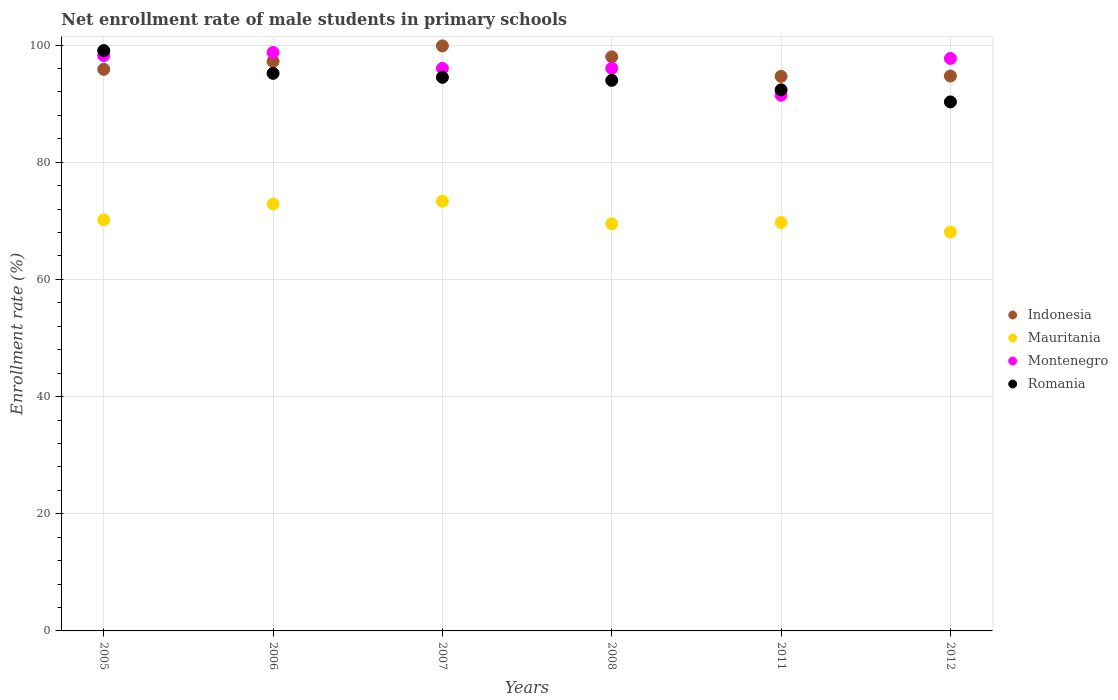Is the number of dotlines equal to the number of legend labels?
Provide a short and direct response. Yes. What is the net enrollment rate of male students in primary schools in Indonesia in 2012?
Make the answer very short. 94.72. Across all years, what is the maximum net enrollment rate of male students in primary schools in Mauritania?
Provide a short and direct response. 73.36. Across all years, what is the minimum net enrollment rate of male students in primary schools in Indonesia?
Your response must be concise. 94.66. What is the total net enrollment rate of male students in primary schools in Indonesia in the graph?
Provide a succinct answer. 580.29. What is the difference between the net enrollment rate of male students in primary schools in Montenegro in 2006 and that in 2007?
Your response must be concise. 2.71. What is the difference between the net enrollment rate of male students in primary schools in Indonesia in 2008 and the net enrollment rate of male students in primary schools in Romania in 2007?
Ensure brevity in your answer.  3.49. What is the average net enrollment rate of male students in primary schools in Montenegro per year?
Offer a very short reply. 96.36. In the year 2008, what is the difference between the net enrollment rate of male students in primary schools in Mauritania and net enrollment rate of male students in primary schools in Romania?
Provide a short and direct response. -24.48. In how many years, is the net enrollment rate of male students in primary schools in Romania greater than 8 %?
Your answer should be very brief. 6. What is the ratio of the net enrollment rate of male students in primary schools in Indonesia in 2011 to that in 2012?
Provide a short and direct response. 1. Is the net enrollment rate of male students in primary schools in Mauritania in 2005 less than that in 2012?
Ensure brevity in your answer.  No. Is the difference between the net enrollment rate of male students in primary schools in Mauritania in 2005 and 2007 greater than the difference between the net enrollment rate of male students in primary schools in Romania in 2005 and 2007?
Ensure brevity in your answer.  No. What is the difference between the highest and the second highest net enrollment rate of male students in primary schools in Indonesia?
Provide a succinct answer. 1.88. What is the difference between the highest and the lowest net enrollment rate of male students in primary schools in Mauritania?
Your response must be concise. 5.27. In how many years, is the net enrollment rate of male students in primary schools in Romania greater than the average net enrollment rate of male students in primary schools in Romania taken over all years?
Give a very brief answer. 3. Is the sum of the net enrollment rate of male students in primary schools in Montenegro in 2006 and 2012 greater than the maximum net enrollment rate of male students in primary schools in Romania across all years?
Your answer should be compact. Yes. Does the net enrollment rate of male students in primary schools in Montenegro monotonically increase over the years?
Make the answer very short. No. Is the net enrollment rate of male students in primary schools in Indonesia strictly greater than the net enrollment rate of male students in primary schools in Mauritania over the years?
Make the answer very short. Yes. How many dotlines are there?
Give a very brief answer. 4. Are the values on the major ticks of Y-axis written in scientific E-notation?
Keep it short and to the point. No. Does the graph contain any zero values?
Make the answer very short. No. Where does the legend appear in the graph?
Provide a short and direct response. Center right. How are the legend labels stacked?
Your response must be concise. Vertical. What is the title of the graph?
Ensure brevity in your answer.  Net enrollment rate of male students in primary schools. What is the label or title of the X-axis?
Your response must be concise. Years. What is the label or title of the Y-axis?
Make the answer very short. Enrollment rate (%). What is the Enrollment rate (%) in Indonesia in 2005?
Give a very brief answer. 95.86. What is the Enrollment rate (%) in Mauritania in 2005?
Your answer should be very brief. 70.17. What is the Enrollment rate (%) of Montenegro in 2005?
Ensure brevity in your answer.  98.2. What is the Enrollment rate (%) of Romania in 2005?
Offer a very short reply. 99.06. What is the Enrollment rate (%) of Indonesia in 2006?
Your response must be concise. 97.21. What is the Enrollment rate (%) in Mauritania in 2006?
Ensure brevity in your answer.  72.87. What is the Enrollment rate (%) in Montenegro in 2006?
Your answer should be very brief. 98.73. What is the Enrollment rate (%) in Romania in 2006?
Give a very brief answer. 95.18. What is the Enrollment rate (%) of Indonesia in 2007?
Provide a succinct answer. 99.86. What is the Enrollment rate (%) in Mauritania in 2007?
Your answer should be compact. 73.36. What is the Enrollment rate (%) of Montenegro in 2007?
Your response must be concise. 96.02. What is the Enrollment rate (%) in Romania in 2007?
Offer a terse response. 94.49. What is the Enrollment rate (%) in Indonesia in 2008?
Ensure brevity in your answer.  97.99. What is the Enrollment rate (%) of Mauritania in 2008?
Offer a very short reply. 69.5. What is the Enrollment rate (%) in Montenegro in 2008?
Keep it short and to the point. 96.04. What is the Enrollment rate (%) in Romania in 2008?
Give a very brief answer. 93.98. What is the Enrollment rate (%) of Indonesia in 2011?
Offer a very short reply. 94.66. What is the Enrollment rate (%) in Mauritania in 2011?
Offer a very short reply. 69.7. What is the Enrollment rate (%) in Montenegro in 2011?
Provide a succinct answer. 91.44. What is the Enrollment rate (%) in Romania in 2011?
Your response must be concise. 92.36. What is the Enrollment rate (%) in Indonesia in 2012?
Offer a terse response. 94.72. What is the Enrollment rate (%) of Mauritania in 2012?
Give a very brief answer. 68.08. What is the Enrollment rate (%) in Montenegro in 2012?
Give a very brief answer. 97.72. What is the Enrollment rate (%) of Romania in 2012?
Your answer should be very brief. 90.3. Across all years, what is the maximum Enrollment rate (%) of Indonesia?
Provide a succinct answer. 99.86. Across all years, what is the maximum Enrollment rate (%) of Mauritania?
Provide a succinct answer. 73.36. Across all years, what is the maximum Enrollment rate (%) of Montenegro?
Make the answer very short. 98.73. Across all years, what is the maximum Enrollment rate (%) of Romania?
Provide a succinct answer. 99.06. Across all years, what is the minimum Enrollment rate (%) in Indonesia?
Provide a short and direct response. 94.66. Across all years, what is the minimum Enrollment rate (%) of Mauritania?
Your answer should be very brief. 68.08. Across all years, what is the minimum Enrollment rate (%) in Montenegro?
Give a very brief answer. 91.44. Across all years, what is the minimum Enrollment rate (%) in Romania?
Offer a terse response. 90.3. What is the total Enrollment rate (%) of Indonesia in the graph?
Provide a succinct answer. 580.29. What is the total Enrollment rate (%) in Mauritania in the graph?
Make the answer very short. 423.67. What is the total Enrollment rate (%) in Montenegro in the graph?
Provide a short and direct response. 578.16. What is the total Enrollment rate (%) of Romania in the graph?
Your response must be concise. 565.36. What is the difference between the Enrollment rate (%) of Indonesia in 2005 and that in 2006?
Provide a succinct answer. -1.35. What is the difference between the Enrollment rate (%) of Mauritania in 2005 and that in 2006?
Give a very brief answer. -2.7. What is the difference between the Enrollment rate (%) of Montenegro in 2005 and that in 2006?
Give a very brief answer. -0.53. What is the difference between the Enrollment rate (%) of Romania in 2005 and that in 2006?
Provide a succinct answer. 3.88. What is the difference between the Enrollment rate (%) in Indonesia in 2005 and that in 2007?
Keep it short and to the point. -4. What is the difference between the Enrollment rate (%) in Mauritania in 2005 and that in 2007?
Provide a short and direct response. -3.19. What is the difference between the Enrollment rate (%) of Montenegro in 2005 and that in 2007?
Offer a very short reply. 2.18. What is the difference between the Enrollment rate (%) of Romania in 2005 and that in 2007?
Your answer should be very brief. 4.57. What is the difference between the Enrollment rate (%) in Indonesia in 2005 and that in 2008?
Keep it short and to the point. -2.13. What is the difference between the Enrollment rate (%) in Mauritania in 2005 and that in 2008?
Keep it short and to the point. 0.67. What is the difference between the Enrollment rate (%) in Montenegro in 2005 and that in 2008?
Make the answer very short. 2.16. What is the difference between the Enrollment rate (%) of Romania in 2005 and that in 2008?
Your answer should be compact. 5.08. What is the difference between the Enrollment rate (%) of Indonesia in 2005 and that in 2011?
Provide a short and direct response. 1.2. What is the difference between the Enrollment rate (%) of Mauritania in 2005 and that in 2011?
Your answer should be compact. 0.46. What is the difference between the Enrollment rate (%) of Montenegro in 2005 and that in 2011?
Offer a terse response. 6.77. What is the difference between the Enrollment rate (%) in Romania in 2005 and that in 2011?
Give a very brief answer. 6.7. What is the difference between the Enrollment rate (%) in Indonesia in 2005 and that in 2012?
Provide a short and direct response. 1.14. What is the difference between the Enrollment rate (%) of Mauritania in 2005 and that in 2012?
Make the answer very short. 2.08. What is the difference between the Enrollment rate (%) of Montenegro in 2005 and that in 2012?
Keep it short and to the point. 0.48. What is the difference between the Enrollment rate (%) in Romania in 2005 and that in 2012?
Keep it short and to the point. 8.76. What is the difference between the Enrollment rate (%) of Indonesia in 2006 and that in 2007?
Your answer should be very brief. -2.65. What is the difference between the Enrollment rate (%) of Mauritania in 2006 and that in 2007?
Offer a terse response. -0.49. What is the difference between the Enrollment rate (%) of Montenegro in 2006 and that in 2007?
Provide a succinct answer. 2.71. What is the difference between the Enrollment rate (%) in Romania in 2006 and that in 2007?
Offer a terse response. 0.69. What is the difference between the Enrollment rate (%) in Indonesia in 2006 and that in 2008?
Your answer should be compact. -0.78. What is the difference between the Enrollment rate (%) of Mauritania in 2006 and that in 2008?
Provide a succinct answer. 3.37. What is the difference between the Enrollment rate (%) of Montenegro in 2006 and that in 2008?
Offer a terse response. 2.7. What is the difference between the Enrollment rate (%) in Romania in 2006 and that in 2008?
Your answer should be compact. 1.2. What is the difference between the Enrollment rate (%) in Indonesia in 2006 and that in 2011?
Make the answer very short. 2.55. What is the difference between the Enrollment rate (%) of Mauritania in 2006 and that in 2011?
Offer a very short reply. 3.16. What is the difference between the Enrollment rate (%) of Montenegro in 2006 and that in 2011?
Provide a short and direct response. 7.3. What is the difference between the Enrollment rate (%) of Romania in 2006 and that in 2011?
Offer a terse response. 2.82. What is the difference between the Enrollment rate (%) in Indonesia in 2006 and that in 2012?
Provide a short and direct response. 2.49. What is the difference between the Enrollment rate (%) in Mauritania in 2006 and that in 2012?
Keep it short and to the point. 4.79. What is the difference between the Enrollment rate (%) in Montenegro in 2006 and that in 2012?
Your answer should be very brief. 1.01. What is the difference between the Enrollment rate (%) of Romania in 2006 and that in 2012?
Provide a short and direct response. 4.88. What is the difference between the Enrollment rate (%) of Indonesia in 2007 and that in 2008?
Ensure brevity in your answer.  1.88. What is the difference between the Enrollment rate (%) in Mauritania in 2007 and that in 2008?
Provide a short and direct response. 3.86. What is the difference between the Enrollment rate (%) in Montenegro in 2007 and that in 2008?
Give a very brief answer. -0.02. What is the difference between the Enrollment rate (%) in Romania in 2007 and that in 2008?
Give a very brief answer. 0.52. What is the difference between the Enrollment rate (%) of Indonesia in 2007 and that in 2011?
Provide a succinct answer. 5.2. What is the difference between the Enrollment rate (%) of Mauritania in 2007 and that in 2011?
Give a very brief answer. 3.65. What is the difference between the Enrollment rate (%) in Montenegro in 2007 and that in 2011?
Your answer should be very brief. 4.59. What is the difference between the Enrollment rate (%) in Romania in 2007 and that in 2011?
Keep it short and to the point. 2.13. What is the difference between the Enrollment rate (%) in Indonesia in 2007 and that in 2012?
Your answer should be very brief. 5.14. What is the difference between the Enrollment rate (%) in Mauritania in 2007 and that in 2012?
Your response must be concise. 5.27. What is the difference between the Enrollment rate (%) of Montenegro in 2007 and that in 2012?
Your response must be concise. -1.7. What is the difference between the Enrollment rate (%) of Romania in 2007 and that in 2012?
Your answer should be very brief. 4.19. What is the difference between the Enrollment rate (%) of Indonesia in 2008 and that in 2011?
Keep it short and to the point. 3.33. What is the difference between the Enrollment rate (%) in Mauritania in 2008 and that in 2011?
Keep it short and to the point. -0.2. What is the difference between the Enrollment rate (%) in Montenegro in 2008 and that in 2011?
Your answer should be very brief. 4.6. What is the difference between the Enrollment rate (%) in Romania in 2008 and that in 2011?
Provide a short and direct response. 1.61. What is the difference between the Enrollment rate (%) in Indonesia in 2008 and that in 2012?
Your answer should be very brief. 3.27. What is the difference between the Enrollment rate (%) in Mauritania in 2008 and that in 2012?
Your response must be concise. 1.42. What is the difference between the Enrollment rate (%) of Montenegro in 2008 and that in 2012?
Keep it short and to the point. -1.68. What is the difference between the Enrollment rate (%) in Romania in 2008 and that in 2012?
Your answer should be compact. 3.68. What is the difference between the Enrollment rate (%) of Indonesia in 2011 and that in 2012?
Your response must be concise. -0.06. What is the difference between the Enrollment rate (%) of Mauritania in 2011 and that in 2012?
Ensure brevity in your answer.  1.62. What is the difference between the Enrollment rate (%) in Montenegro in 2011 and that in 2012?
Your answer should be very brief. -6.29. What is the difference between the Enrollment rate (%) in Romania in 2011 and that in 2012?
Make the answer very short. 2.06. What is the difference between the Enrollment rate (%) of Indonesia in 2005 and the Enrollment rate (%) of Mauritania in 2006?
Your answer should be compact. 22.99. What is the difference between the Enrollment rate (%) of Indonesia in 2005 and the Enrollment rate (%) of Montenegro in 2006?
Your answer should be very brief. -2.88. What is the difference between the Enrollment rate (%) of Indonesia in 2005 and the Enrollment rate (%) of Romania in 2006?
Keep it short and to the point. 0.68. What is the difference between the Enrollment rate (%) of Mauritania in 2005 and the Enrollment rate (%) of Montenegro in 2006?
Offer a very short reply. -28.57. What is the difference between the Enrollment rate (%) in Mauritania in 2005 and the Enrollment rate (%) in Romania in 2006?
Provide a short and direct response. -25.01. What is the difference between the Enrollment rate (%) of Montenegro in 2005 and the Enrollment rate (%) of Romania in 2006?
Make the answer very short. 3.03. What is the difference between the Enrollment rate (%) in Indonesia in 2005 and the Enrollment rate (%) in Mauritania in 2007?
Make the answer very short. 22.5. What is the difference between the Enrollment rate (%) of Indonesia in 2005 and the Enrollment rate (%) of Montenegro in 2007?
Give a very brief answer. -0.17. What is the difference between the Enrollment rate (%) of Indonesia in 2005 and the Enrollment rate (%) of Romania in 2007?
Your response must be concise. 1.37. What is the difference between the Enrollment rate (%) in Mauritania in 2005 and the Enrollment rate (%) in Montenegro in 2007?
Keep it short and to the point. -25.86. What is the difference between the Enrollment rate (%) of Mauritania in 2005 and the Enrollment rate (%) of Romania in 2007?
Offer a very short reply. -24.33. What is the difference between the Enrollment rate (%) of Montenegro in 2005 and the Enrollment rate (%) of Romania in 2007?
Offer a very short reply. 3.71. What is the difference between the Enrollment rate (%) in Indonesia in 2005 and the Enrollment rate (%) in Mauritania in 2008?
Make the answer very short. 26.36. What is the difference between the Enrollment rate (%) in Indonesia in 2005 and the Enrollment rate (%) in Montenegro in 2008?
Your answer should be compact. -0.18. What is the difference between the Enrollment rate (%) in Indonesia in 2005 and the Enrollment rate (%) in Romania in 2008?
Your answer should be very brief. 1.88. What is the difference between the Enrollment rate (%) in Mauritania in 2005 and the Enrollment rate (%) in Montenegro in 2008?
Provide a succinct answer. -25.87. What is the difference between the Enrollment rate (%) in Mauritania in 2005 and the Enrollment rate (%) in Romania in 2008?
Offer a terse response. -23.81. What is the difference between the Enrollment rate (%) in Montenegro in 2005 and the Enrollment rate (%) in Romania in 2008?
Give a very brief answer. 4.23. What is the difference between the Enrollment rate (%) of Indonesia in 2005 and the Enrollment rate (%) of Mauritania in 2011?
Your answer should be very brief. 26.15. What is the difference between the Enrollment rate (%) of Indonesia in 2005 and the Enrollment rate (%) of Montenegro in 2011?
Ensure brevity in your answer.  4.42. What is the difference between the Enrollment rate (%) of Indonesia in 2005 and the Enrollment rate (%) of Romania in 2011?
Offer a terse response. 3.5. What is the difference between the Enrollment rate (%) in Mauritania in 2005 and the Enrollment rate (%) in Montenegro in 2011?
Your answer should be very brief. -21.27. What is the difference between the Enrollment rate (%) in Mauritania in 2005 and the Enrollment rate (%) in Romania in 2011?
Ensure brevity in your answer.  -22.2. What is the difference between the Enrollment rate (%) in Montenegro in 2005 and the Enrollment rate (%) in Romania in 2011?
Your response must be concise. 5.84. What is the difference between the Enrollment rate (%) in Indonesia in 2005 and the Enrollment rate (%) in Mauritania in 2012?
Your answer should be compact. 27.78. What is the difference between the Enrollment rate (%) of Indonesia in 2005 and the Enrollment rate (%) of Montenegro in 2012?
Offer a very short reply. -1.86. What is the difference between the Enrollment rate (%) in Indonesia in 2005 and the Enrollment rate (%) in Romania in 2012?
Give a very brief answer. 5.56. What is the difference between the Enrollment rate (%) in Mauritania in 2005 and the Enrollment rate (%) in Montenegro in 2012?
Offer a terse response. -27.56. What is the difference between the Enrollment rate (%) in Mauritania in 2005 and the Enrollment rate (%) in Romania in 2012?
Your answer should be very brief. -20.13. What is the difference between the Enrollment rate (%) of Montenegro in 2005 and the Enrollment rate (%) of Romania in 2012?
Give a very brief answer. 7.9. What is the difference between the Enrollment rate (%) of Indonesia in 2006 and the Enrollment rate (%) of Mauritania in 2007?
Give a very brief answer. 23.85. What is the difference between the Enrollment rate (%) in Indonesia in 2006 and the Enrollment rate (%) in Montenegro in 2007?
Your answer should be very brief. 1.18. What is the difference between the Enrollment rate (%) of Indonesia in 2006 and the Enrollment rate (%) of Romania in 2007?
Keep it short and to the point. 2.72. What is the difference between the Enrollment rate (%) of Mauritania in 2006 and the Enrollment rate (%) of Montenegro in 2007?
Provide a short and direct response. -23.16. What is the difference between the Enrollment rate (%) of Mauritania in 2006 and the Enrollment rate (%) of Romania in 2007?
Give a very brief answer. -21.63. What is the difference between the Enrollment rate (%) of Montenegro in 2006 and the Enrollment rate (%) of Romania in 2007?
Your answer should be very brief. 4.24. What is the difference between the Enrollment rate (%) in Indonesia in 2006 and the Enrollment rate (%) in Mauritania in 2008?
Offer a terse response. 27.71. What is the difference between the Enrollment rate (%) of Indonesia in 2006 and the Enrollment rate (%) of Montenegro in 2008?
Provide a short and direct response. 1.17. What is the difference between the Enrollment rate (%) of Indonesia in 2006 and the Enrollment rate (%) of Romania in 2008?
Ensure brevity in your answer.  3.23. What is the difference between the Enrollment rate (%) in Mauritania in 2006 and the Enrollment rate (%) in Montenegro in 2008?
Provide a succinct answer. -23.17. What is the difference between the Enrollment rate (%) of Mauritania in 2006 and the Enrollment rate (%) of Romania in 2008?
Provide a succinct answer. -21.11. What is the difference between the Enrollment rate (%) of Montenegro in 2006 and the Enrollment rate (%) of Romania in 2008?
Keep it short and to the point. 4.76. What is the difference between the Enrollment rate (%) of Indonesia in 2006 and the Enrollment rate (%) of Mauritania in 2011?
Offer a very short reply. 27.5. What is the difference between the Enrollment rate (%) in Indonesia in 2006 and the Enrollment rate (%) in Montenegro in 2011?
Your response must be concise. 5.77. What is the difference between the Enrollment rate (%) of Indonesia in 2006 and the Enrollment rate (%) of Romania in 2011?
Your answer should be compact. 4.85. What is the difference between the Enrollment rate (%) of Mauritania in 2006 and the Enrollment rate (%) of Montenegro in 2011?
Your answer should be compact. -18.57. What is the difference between the Enrollment rate (%) in Mauritania in 2006 and the Enrollment rate (%) in Romania in 2011?
Your answer should be compact. -19.49. What is the difference between the Enrollment rate (%) in Montenegro in 2006 and the Enrollment rate (%) in Romania in 2011?
Give a very brief answer. 6.37. What is the difference between the Enrollment rate (%) in Indonesia in 2006 and the Enrollment rate (%) in Mauritania in 2012?
Provide a succinct answer. 29.13. What is the difference between the Enrollment rate (%) of Indonesia in 2006 and the Enrollment rate (%) of Montenegro in 2012?
Offer a very short reply. -0.51. What is the difference between the Enrollment rate (%) in Indonesia in 2006 and the Enrollment rate (%) in Romania in 2012?
Give a very brief answer. 6.91. What is the difference between the Enrollment rate (%) in Mauritania in 2006 and the Enrollment rate (%) in Montenegro in 2012?
Provide a succinct answer. -24.86. What is the difference between the Enrollment rate (%) of Mauritania in 2006 and the Enrollment rate (%) of Romania in 2012?
Keep it short and to the point. -17.43. What is the difference between the Enrollment rate (%) of Montenegro in 2006 and the Enrollment rate (%) of Romania in 2012?
Provide a short and direct response. 8.44. What is the difference between the Enrollment rate (%) in Indonesia in 2007 and the Enrollment rate (%) in Mauritania in 2008?
Provide a short and direct response. 30.36. What is the difference between the Enrollment rate (%) of Indonesia in 2007 and the Enrollment rate (%) of Montenegro in 2008?
Ensure brevity in your answer.  3.82. What is the difference between the Enrollment rate (%) of Indonesia in 2007 and the Enrollment rate (%) of Romania in 2008?
Offer a terse response. 5.89. What is the difference between the Enrollment rate (%) of Mauritania in 2007 and the Enrollment rate (%) of Montenegro in 2008?
Your answer should be compact. -22.68. What is the difference between the Enrollment rate (%) in Mauritania in 2007 and the Enrollment rate (%) in Romania in 2008?
Provide a short and direct response. -20.62. What is the difference between the Enrollment rate (%) of Montenegro in 2007 and the Enrollment rate (%) of Romania in 2008?
Your answer should be compact. 2.05. What is the difference between the Enrollment rate (%) in Indonesia in 2007 and the Enrollment rate (%) in Mauritania in 2011?
Ensure brevity in your answer.  30.16. What is the difference between the Enrollment rate (%) in Indonesia in 2007 and the Enrollment rate (%) in Montenegro in 2011?
Make the answer very short. 8.43. What is the difference between the Enrollment rate (%) of Indonesia in 2007 and the Enrollment rate (%) of Romania in 2011?
Make the answer very short. 7.5. What is the difference between the Enrollment rate (%) in Mauritania in 2007 and the Enrollment rate (%) in Montenegro in 2011?
Make the answer very short. -18.08. What is the difference between the Enrollment rate (%) of Mauritania in 2007 and the Enrollment rate (%) of Romania in 2011?
Make the answer very short. -19. What is the difference between the Enrollment rate (%) of Montenegro in 2007 and the Enrollment rate (%) of Romania in 2011?
Keep it short and to the point. 3.66. What is the difference between the Enrollment rate (%) of Indonesia in 2007 and the Enrollment rate (%) of Mauritania in 2012?
Keep it short and to the point. 31.78. What is the difference between the Enrollment rate (%) of Indonesia in 2007 and the Enrollment rate (%) of Montenegro in 2012?
Make the answer very short. 2.14. What is the difference between the Enrollment rate (%) of Indonesia in 2007 and the Enrollment rate (%) of Romania in 2012?
Your answer should be very brief. 9.56. What is the difference between the Enrollment rate (%) of Mauritania in 2007 and the Enrollment rate (%) of Montenegro in 2012?
Ensure brevity in your answer.  -24.37. What is the difference between the Enrollment rate (%) in Mauritania in 2007 and the Enrollment rate (%) in Romania in 2012?
Ensure brevity in your answer.  -16.94. What is the difference between the Enrollment rate (%) in Montenegro in 2007 and the Enrollment rate (%) in Romania in 2012?
Offer a terse response. 5.73. What is the difference between the Enrollment rate (%) in Indonesia in 2008 and the Enrollment rate (%) in Mauritania in 2011?
Offer a very short reply. 28.28. What is the difference between the Enrollment rate (%) of Indonesia in 2008 and the Enrollment rate (%) of Montenegro in 2011?
Provide a short and direct response. 6.55. What is the difference between the Enrollment rate (%) of Indonesia in 2008 and the Enrollment rate (%) of Romania in 2011?
Keep it short and to the point. 5.63. What is the difference between the Enrollment rate (%) in Mauritania in 2008 and the Enrollment rate (%) in Montenegro in 2011?
Your response must be concise. -21.94. What is the difference between the Enrollment rate (%) of Mauritania in 2008 and the Enrollment rate (%) of Romania in 2011?
Keep it short and to the point. -22.86. What is the difference between the Enrollment rate (%) of Montenegro in 2008 and the Enrollment rate (%) of Romania in 2011?
Offer a very short reply. 3.68. What is the difference between the Enrollment rate (%) of Indonesia in 2008 and the Enrollment rate (%) of Mauritania in 2012?
Your response must be concise. 29.91. What is the difference between the Enrollment rate (%) in Indonesia in 2008 and the Enrollment rate (%) in Montenegro in 2012?
Your answer should be compact. 0.26. What is the difference between the Enrollment rate (%) in Indonesia in 2008 and the Enrollment rate (%) in Romania in 2012?
Make the answer very short. 7.69. What is the difference between the Enrollment rate (%) of Mauritania in 2008 and the Enrollment rate (%) of Montenegro in 2012?
Provide a succinct answer. -28.22. What is the difference between the Enrollment rate (%) of Mauritania in 2008 and the Enrollment rate (%) of Romania in 2012?
Provide a short and direct response. -20.8. What is the difference between the Enrollment rate (%) in Montenegro in 2008 and the Enrollment rate (%) in Romania in 2012?
Your answer should be compact. 5.74. What is the difference between the Enrollment rate (%) of Indonesia in 2011 and the Enrollment rate (%) of Mauritania in 2012?
Keep it short and to the point. 26.58. What is the difference between the Enrollment rate (%) in Indonesia in 2011 and the Enrollment rate (%) in Montenegro in 2012?
Your answer should be compact. -3.06. What is the difference between the Enrollment rate (%) in Indonesia in 2011 and the Enrollment rate (%) in Romania in 2012?
Ensure brevity in your answer.  4.36. What is the difference between the Enrollment rate (%) of Mauritania in 2011 and the Enrollment rate (%) of Montenegro in 2012?
Give a very brief answer. -28.02. What is the difference between the Enrollment rate (%) in Mauritania in 2011 and the Enrollment rate (%) in Romania in 2012?
Your response must be concise. -20.59. What is the difference between the Enrollment rate (%) of Montenegro in 2011 and the Enrollment rate (%) of Romania in 2012?
Your response must be concise. 1.14. What is the average Enrollment rate (%) of Indonesia per year?
Provide a short and direct response. 96.72. What is the average Enrollment rate (%) in Mauritania per year?
Ensure brevity in your answer.  70.61. What is the average Enrollment rate (%) of Montenegro per year?
Your answer should be very brief. 96.36. What is the average Enrollment rate (%) in Romania per year?
Your answer should be very brief. 94.23. In the year 2005, what is the difference between the Enrollment rate (%) in Indonesia and Enrollment rate (%) in Mauritania?
Offer a very short reply. 25.69. In the year 2005, what is the difference between the Enrollment rate (%) in Indonesia and Enrollment rate (%) in Montenegro?
Ensure brevity in your answer.  -2.35. In the year 2005, what is the difference between the Enrollment rate (%) of Indonesia and Enrollment rate (%) of Romania?
Your response must be concise. -3.2. In the year 2005, what is the difference between the Enrollment rate (%) in Mauritania and Enrollment rate (%) in Montenegro?
Provide a succinct answer. -28.04. In the year 2005, what is the difference between the Enrollment rate (%) in Mauritania and Enrollment rate (%) in Romania?
Provide a succinct answer. -28.89. In the year 2005, what is the difference between the Enrollment rate (%) of Montenegro and Enrollment rate (%) of Romania?
Make the answer very short. -0.86. In the year 2006, what is the difference between the Enrollment rate (%) in Indonesia and Enrollment rate (%) in Mauritania?
Ensure brevity in your answer.  24.34. In the year 2006, what is the difference between the Enrollment rate (%) in Indonesia and Enrollment rate (%) in Montenegro?
Your response must be concise. -1.53. In the year 2006, what is the difference between the Enrollment rate (%) of Indonesia and Enrollment rate (%) of Romania?
Ensure brevity in your answer.  2.03. In the year 2006, what is the difference between the Enrollment rate (%) in Mauritania and Enrollment rate (%) in Montenegro?
Offer a terse response. -25.87. In the year 2006, what is the difference between the Enrollment rate (%) of Mauritania and Enrollment rate (%) of Romania?
Provide a succinct answer. -22.31. In the year 2006, what is the difference between the Enrollment rate (%) of Montenegro and Enrollment rate (%) of Romania?
Ensure brevity in your answer.  3.56. In the year 2007, what is the difference between the Enrollment rate (%) of Indonesia and Enrollment rate (%) of Mauritania?
Make the answer very short. 26.51. In the year 2007, what is the difference between the Enrollment rate (%) of Indonesia and Enrollment rate (%) of Montenegro?
Provide a short and direct response. 3.84. In the year 2007, what is the difference between the Enrollment rate (%) in Indonesia and Enrollment rate (%) in Romania?
Provide a succinct answer. 5.37. In the year 2007, what is the difference between the Enrollment rate (%) of Mauritania and Enrollment rate (%) of Montenegro?
Make the answer very short. -22.67. In the year 2007, what is the difference between the Enrollment rate (%) in Mauritania and Enrollment rate (%) in Romania?
Provide a short and direct response. -21.14. In the year 2007, what is the difference between the Enrollment rate (%) in Montenegro and Enrollment rate (%) in Romania?
Your answer should be very brief. 1.53. In the year 2008, what is the difference between the Enrollment rate (%) in Indonesia and Enrollment rate (%) in Mauritania?
Provide a succinct answer. 28.49. In the year 2008, what is the difference between the Enrollment rate (%) in Indonesia and Enrollment rate (%) in Montenegro?
Your answer should be very brief. 1.95. In the year 2008, what is the difference between the Enrollment rate (%) in Indonesia and Enrollment rate (%) in Romania?
Your answer should be very brief. 4.01. In the year 2008, what is the difference between the Enrollment rate (%) of Mauritania and Enrollment rate (%) of Montenegro?
Offer a terse response. -26.54. In the year 2008, what is the difference between the Enrollment rate (%) of Mauritania and Enrollment rate (%) of Romania?
Offer a terse response. -24.48. In the year 2008, what is the difference between the Enrollment rate (%) in Montenegro and Enrollment rate (%) in Romania?
Your answer should be compact. 2.06. In the year 2011, what is the difference between the Enrollment rate (%) in Indonesia and Enrollment rate (%) in Mauritania?
Your response must be concise. 24.96. In the year 2011, what is the difference between the Enrollment rate (%) in Indonesia and Enrollment rate (%) in Montenegro?
Your answer should be compact. 3.22. In the year 2011, what is the difference between the Enrollment rate (%) of Indonesia and Enrollment rate (%) of Romania?
Ensure brevity in your answer.  2.3. In the year 2011, what is the difference between the Enrollment rate (%) of Mauritania and Enrollment rate (%) of Montenegro?
Give a very brief answer. -21.73. In the year 2011, what is the difference between the Enrollment rate (%) in Mauritania and Enrollment rate (%) in Romania?
Your answer should be very brief. -22.66. In the year 2011, what is the difference between the Enrollment rate (%) of Montenegro and Enrollment rate (%) of Romania?
Your answer should be compact. -0.93. In the year 2012, what is the difference between the Enrollment rate (%) of Indonesia and Enrollment rate (%) of Mauritania?
Keep it short and to the point. 26.64. In the year 2012, what is the difference between the Enrollment rate (%) in Indonesia and Enrollment rate (%) in Montenegro?
Provide a succinct answer. -3. In the year 2012, what is the difference between the Enrollment rate (%) of Indonesia and Enrollment rate (%) of Romania?
Give a very brief answer. 4.42. In the year 2012, what is the difference between the Enrollment rate (%) of Mauritania and Enrollment rate (%) of Montenegro?
Give a very brief answer. -29.64. In the year 2012, what is the difference between the Enrollment rate (%) in Mauritania and Enrollment rate (%) in Romania?
Keep it short and to the point. -22.22. In the year 2012, what is the difference between the Enrollment rate (%) of Montenegro and Enrollment rate (%) of Romania?
Your answer should be very brief. 7.42. What is the ratio of the Enrollment rate (%) of Indonesia in 2005 to that in 2006?
Make the answer very short. 0.99. What is the ratio of the Enrollment rate (%) in Mauritania in 2005 to that in 2006?
Provide a succinct answer. 0.96. What is the ratio of the Enrollment rate (%) in Montenegro in 2005 to that in 2006?
Offer a terse response. 0.99. What is the ratio of the Enrollment rate (%) of Romania in 2005 to that in 2006?
Keep it short and to the point. 1.04. What is the ratio of the Enrollment rate (%) in Indonesia in 2005 to that in 2007?
Ensure brevity in your answer.  0.96. What is the ratio of the Enrollment rate (%) in Mauritania in 2005 to that in 2007?
Provide a short and direct response. 0.96. What is the ratio of the Enrollment rate (%) in Montenegro in 2005 to that in 2007?
Make the answer very short. 1.02. What is the ratio of the Enrollment rate (%) of Romania in 2005 to that in 2007?
Keep it short and to the point. 1.05. What is the ratio of the Enrollment rate (%) of Indonesia in 2005 to that in 2008?
Your response must be concise. 0.98. What is the ratio of the Enrollment rate (%) in Mauritania in 2005 to that in 2008?
Make the answer very short. 1.01. What is the ratio of the Enrollment rate (%) of Montenegro in 2005 to that in 2008?
Keep it short and to the point. 1.02. What is the ratio of the Enrollment rate (%) of Romania in 2005 to that in 2008?
Your response must be concise. 1.05. What is the ratio of the Enrollment rate (%) of Indonesia in 2005 to that in 2011?
Keep it short and to the point. 1.01. What is the ratio of the Enrollment rate (%) of Mauritania in 2005 to that in 2011?
Your response must be concise. 1.01. What is the ratio of the Enrollment rate (%) of Montenegro in 2005 to that in 2011?
Give a very brief answer. 1.07. What is the ratio of the Enrollment rate (%) in Romania in 2005 to that in 2011?
Your answer should be very brief. 1.07. What is the ratio of the Enrollment rate (%) of Mauritania in 2005 to that in 2012?
Offer a terse response. 1.03. What is the ratio of the Enrollment rate (%) in Romania in 2005 to that in 2012?
Your answer should be very brief. 1.1. What is the ratio of the Enrollment rate (%) in Indonesia in 2006 to that in 2007?
Ensure brevity in your answer.  0.97. What is the ratio of the Enrollment rate (%) of Montenegro in 2006 to that in 2007?
Offer a terse response. 1.03. What is the ratio of the Enrollment rate (%) in Mauritania in 2006 to that in 2008?
Your response must be concise. 1.05. What is the ratio of the Enrollment rate (%) of Montenegro in 2006 to that in 2008?
Your answer should be compact. 1.03. What is the ratio of the Enrollment rate (%) in Romania in 2006 to that in 2008?
Your answer should be compact. 1.01. What is the ratio of the Enrollment rate (%) in Indonesia in 2006 to that in 2011?
Your answer should be very brief. 1.03. What is the ratio of the Enrollment rate (%) in Mauritania in 2006 to that in 2011?
Offer a terse response. 1.05. What is the ratio of the Enrollment rate (%) in Montenegro in 2006 to that in 2011?
Offer a very short reply. 1.08. What is the ratio of the Enrollment rate (%) in Romania in 2006 to that in 2011?
Keep it short and to the point. 1.03. What is the ratio of the Enrollment rate (%) of Indonesia in 2006 to that in 2012?
Your answer should be compact. 1.03. What is the ratio of the Enrollment rate (%) in Mauritania in 2006 to that in 2012?
Offer a very short reply. 1.07. What is the ratio of the Enrollment rate (%) in Montenegro in 2006 to that in 2012?
Offer a terse response. 1.01. What is the ratio of the Enrollment rate (%) of Romania in 2006 to that in 2012?
Your answer should be compact. 1.05. What is the ratio of the Enrollment rate (%) in Indonesia in 2007 to that in 2008?
Your answer should be compact. 1.02. What is the ratio of the Enrollment rate (%) of Mauritania in 2007 to that in 2008?
Your answer should be very brief. 1.06. What is the ratio of the Enrollment rate (%) of Montenegro in 2007 to that in 2008?
Provide a short and direct response. 1. What is the ratio of the Enrollment rate (%) in Romania in 2007 to that in 2008?
Provide a short and direct response. 1.01. What is the ratio of the Enrollment rate (%) in Indonesia in 2007 to that in 2011?
Give a very brief answer. 1.05. What is the ratio of the Enrollment rate (%) in Mauritania in 2007 to that in 2011?
Provide a short and direct response. 1.05. What is the ratio of the Enrollment rate (%) in Montenegro in 2007 to that in 2011?
Keep it short and to the point. 1.05. What is the ratio of the Enrollment rate (%) in Romania in 2007 to that in 2011?
Give a very brief answer. 1.02. What is the ratio of the Enrollment rate (%) in Indonesia in 2007 to that in 2012?
Offer a very short reply. 1.05. What is the ratio of the Enrollment rate (%) of Mauritania in 2007 to that in 2012?
Your response must be concise. 1.08. What is the ratio of the Enrollment rate (%) in Montenegro in 2007 to that in 2012?
Give a very brief answer. 0.98. What is the ratio of the Enrollment rate (%) of Romania in 2007 to that in 2012?
Your answer should be compact. 1.05. What is the ratio of the Enrollment rate (%) of Indonesia in 2008 to that in 2011?
Provide a short and direct response. 1.04. What is the ratio of the Enrollment rate (%) in Mauritania in 2008 to that in 2011?
Provide a short and direct response. 1. What is the ratio of the Enrollment rate (%) in Montenegro in 2008 to that in 2011?
Give a very brief answer. 1.05. What is the ratio of the Enrollment rate (%) in Romania in 2008 to that in 2011?
Provide a succinct answer. 1.02. What is the ratio of the Enrollment rate (%) of Indonesia in 2008 to that in 2012?
Offer a very short reply. 1.03. What is the ratio of the Enrollment rate (%) in Mauritania in 2008 to that in 2012?
Your answer should be compact. 1.02. What is the ratio of the Enrollment rate (%) in Montenegro in 2008 to that in 2012?
Provide a short and direct response. 0.98. What is the ratio of the Enrollment rate (%) in Romania in 2008 to that in 2012?
Give a very brief answer. 1.04. What is the ratio of the Enrollment rate (%) of Mauritania in 2011 to that in 2012?
Provide a short and direct response. 1.02. What is the ratio of the Enrollment rate (%) of Montenegro in 2011 to that in 2012?
Provide a short and direct response. 0.94. What is the ratio of the Enrollment rate (%) of Romania in 2011 to that in 2012?
Your answer should be compact. 1.02. What is the difference between the highest and the second highest Enrollment rate (%) of Indonesia?
Give a very brief answer. 1.88. What is the difference between the highest and the second highest Enrollment rate (%) of Mauritania?
Your answer should be very brief. 0.49. What is the difference between the highest and the second highest Enrollment rate (%) in Montenegro?
Your answer should be compact. 0.53. What is the difference between the highest and the second highest Enrollment rate (%) of Romania?
Offer a very short reply. 3.88. What is the difference between the highest and the lowest Enrollment rate (%) in Indonesia?
Your answer should be compact. 5.2. What is the difference between the highest and the lowest Enrollment rate (%) in Mauritania?
Your response must be concise. 5.27. What is the difference between the highest and the lowest Enrollment rate (%) in Montenegro?
Ensure brevity in your answer.  7.3. What is the difference between the highest and the lowest Enrollment rate (%) of Romania?
Provide a short and direct response. 8.76. 